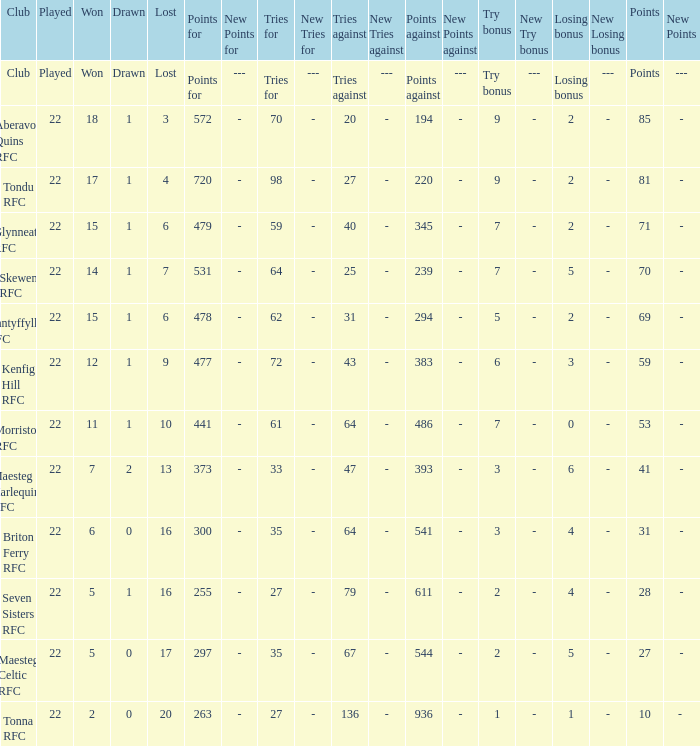How many tries against got the club with 62 tries for? 31.0. 